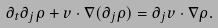<formula> <loc_0><loc_0><loc_500><loc_500>\partial _ { t } \partial _ { j } \rho + v \cdot \nabla ( \partial _ { j } \rho ) = \partial _ { j } v \cdot \nabla \rho .</formula> 